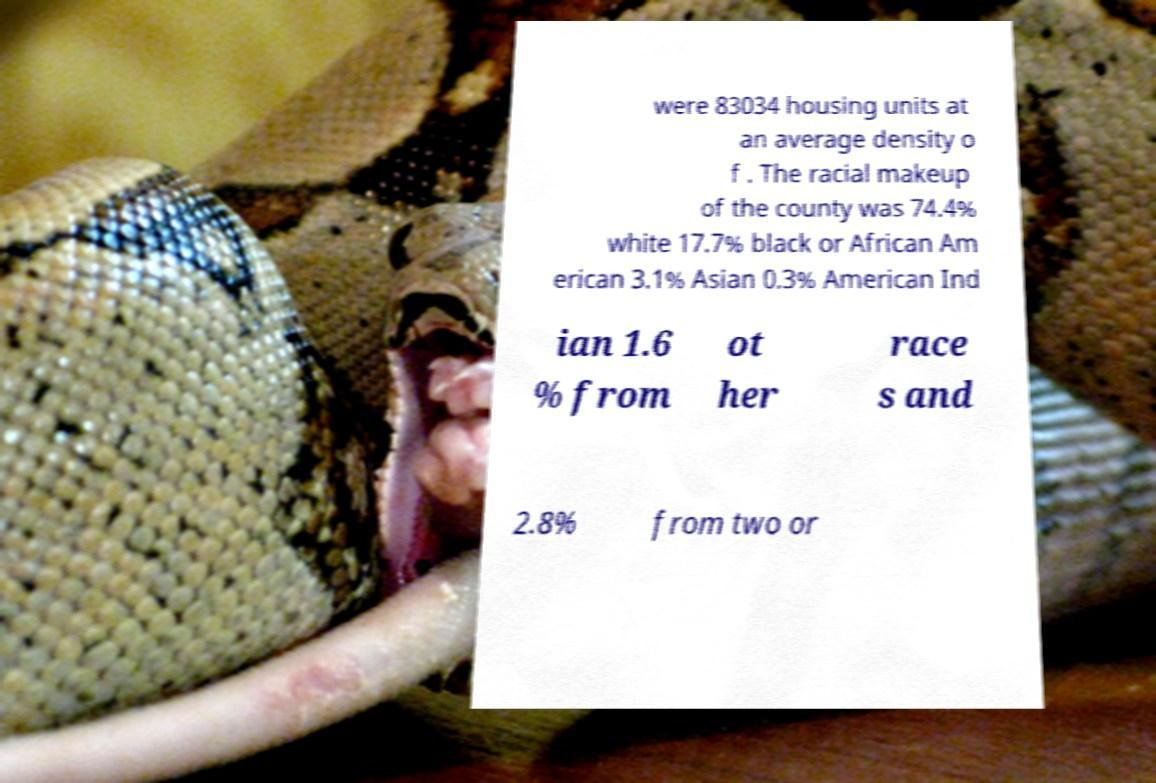What messages or text are displayed in this image? I need them in a readable, typed format. were 83034 housing units at an average density o f . The racial makeup of the county was 74.4% white 17.7% black or African Am erican 3.1% Asian 0.3% American Ind ian 1.6 % from ot her race s and 2.8% from two or 